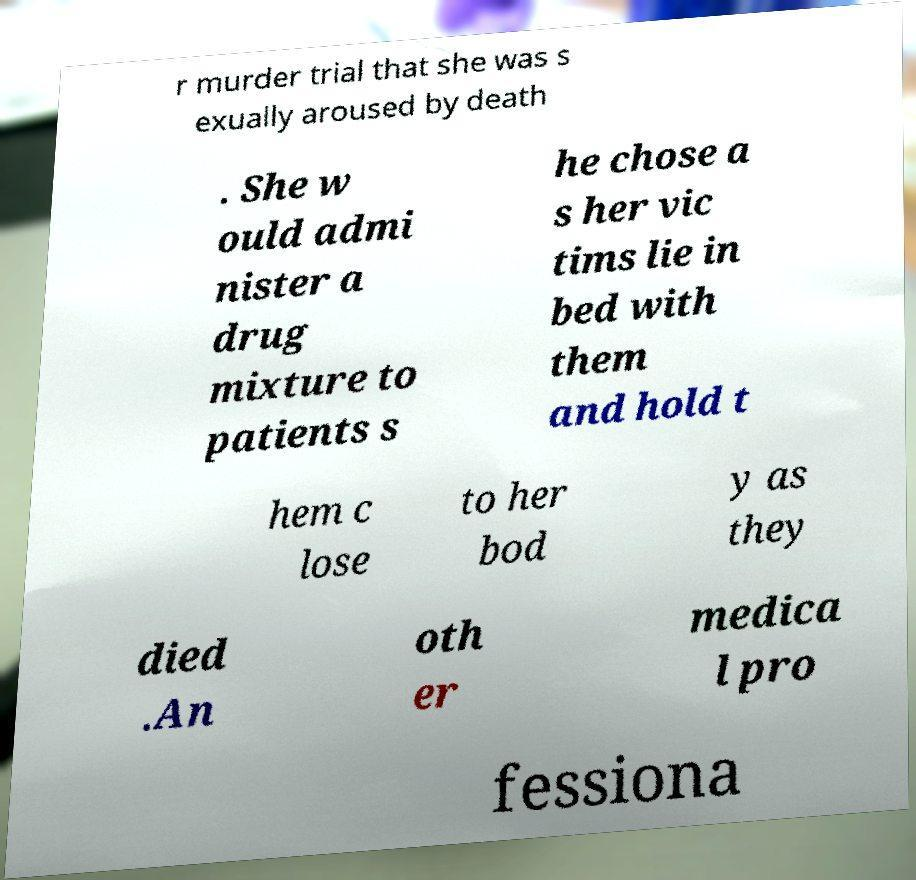Could you extract and type out the text from this image? r murder trial that she was s exually aroused by death . She w ould admi nister a drug mixture to patients s he chose a s her vic tims lie in bed with them and hold t hem c lose to her bod y as they died .An oth er medica l pro fessiona 